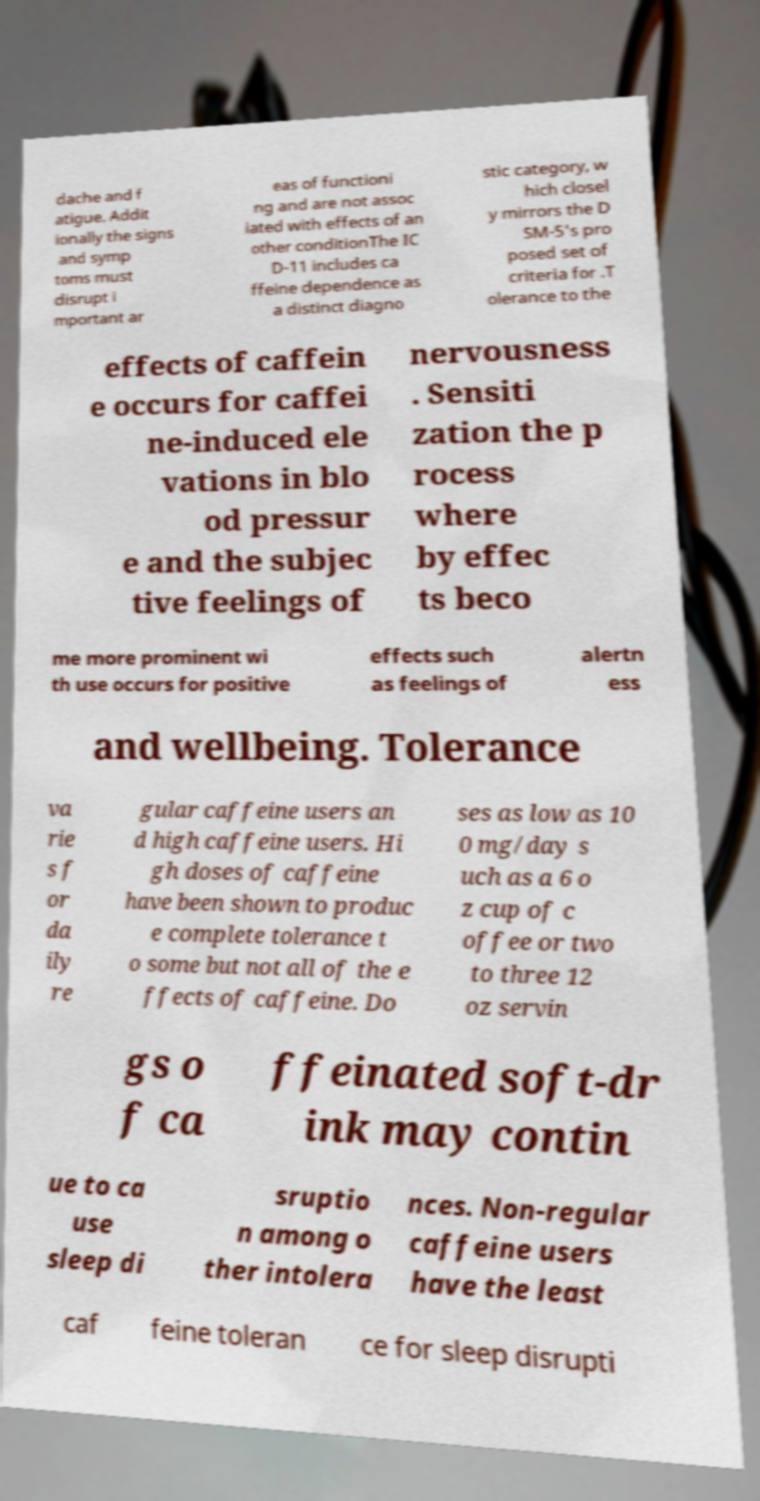Could you extract and type out the text from this image? dache and f atigue. Addit ionally the signs and symp toms must disrupt i mportant ar eas of functioni ng and are not assoc iated with effects of an other conditionThe IC D-11 includes ca ffeine dependence as a distinct diagno stic category, w hich closel y mirrors the D SM-5's pro posed set of criteria for .T olerance to the effects of caffein e occurs for caffei ne-induced ele vations in blo od pressur e and the subjec tive feelings of nervousness . Sensiti zation the p rocess where by effec ts beco me more prominent wi th use occurs for positive effects such as feelings of alertn ess and wellbeing. Tolerance va rie s f or da ily re gular caffeine users an d high caffeine users. Hi gh doses of caffeine have been shown to produc e complete tolerance t o some but not all of the e ffects of caffeine. Do ses as low as 10 0 mg/day s uch as a 6 o z cup of c offee or two to three 12 oz servin gs o f ca ffeinated soft-dr ink may contin ue to ca use sleep di sruptio n among o ther intolera nces. Non-regular caffeine users have the least caf feine toleran ce for sleep disrupti 